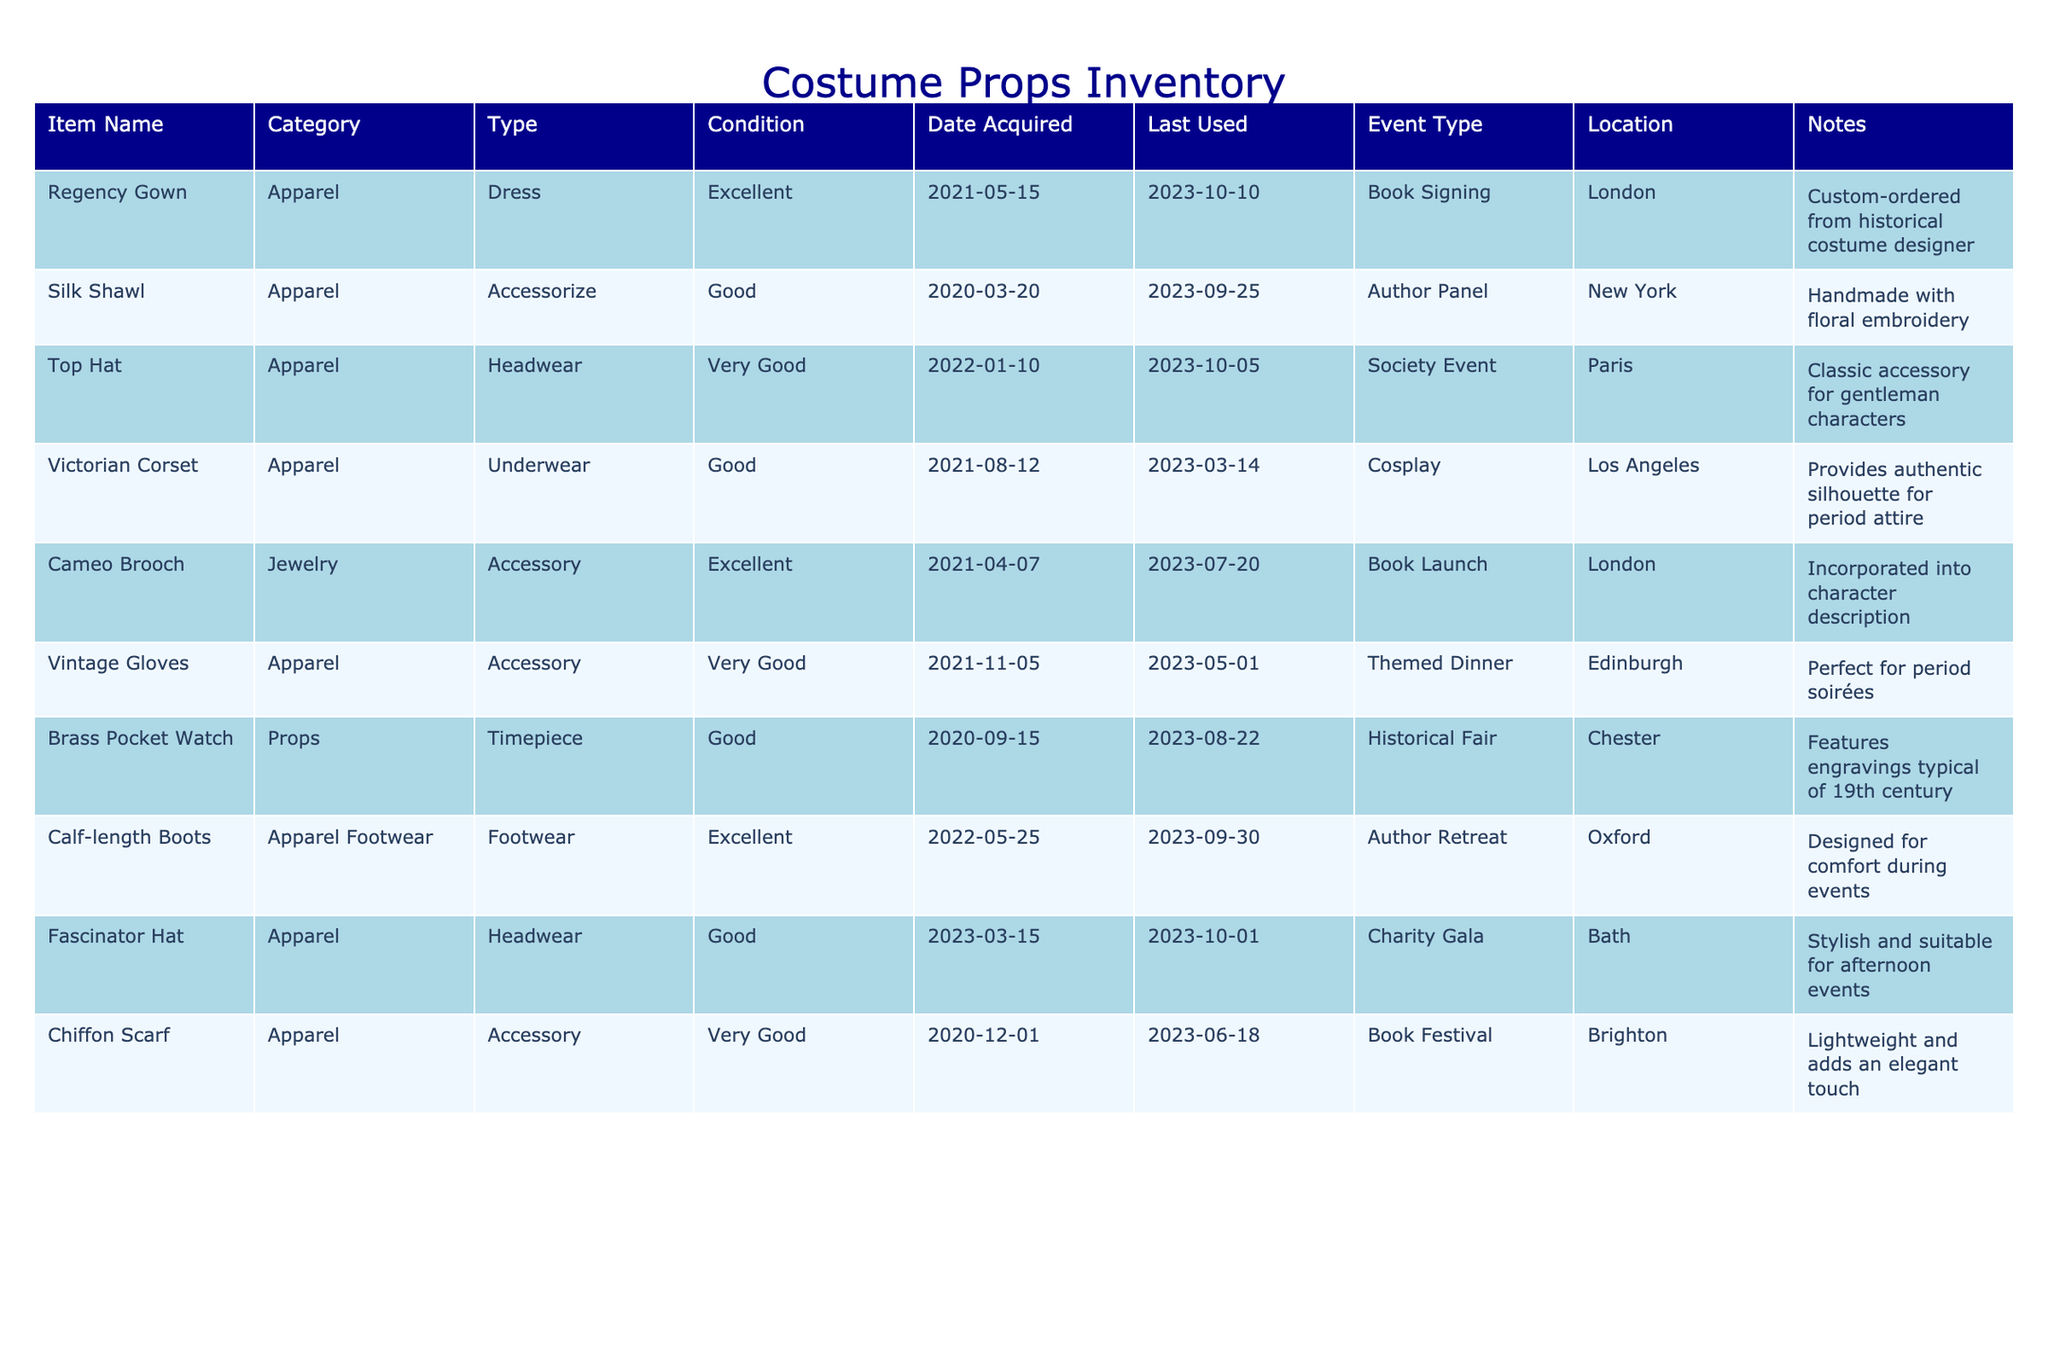What is the condition of the Silk Shawl? The condition of the Silk Shawl can be found by searching for its row in the table. It states that the condition is "Good".
Answer: Good When was the Victorian Corset last used? To find this information, locate the row for the Victorian Corset in the table, where the "Last Used" column indicates that it was last used on "2023-03-14".
Answer: 2023-03-14 How many items were acquired in the year 2021? A deeper examination of the "Date Acquired" column reveals that there are three items acquired in 2021: Regency Gown, Victorian Corset, and Cameo Brooch.
Answer: 3 Is the Top Hat suitable for a Society Event? Looking at the "Event Type" for Top Hat, it lists "Society Event", implying it is indeed suitable for such occasions.
Answer: Yes What is the average condition rating of the costume accessories? Evaluating the conditions listed (Excellent, Good, Very Good, etc.) and determining their assigned values (Excellent=2, Good=1, Very Good=1.5), we identify the condition ratings of the accessories: Silk Shawl (1), Cameo Brooch (2), Vintage Gloves (1.5), Chiffon Scarf (1.5). The average is calculated as (1 + 2 + 1.5 + 1.5) / 4 = 1.75.
Answer: 1.75 How often is the Brass Pocket Watch used for events? By assessing the dates in the "Last Used" column in relation to its "Date Acquired" (2020-09-15), we see it has been used in one event in 2023 -- this indicates it has been used sparingly over the two years since acquisition.
Answer: Sparingly Which item was custom-ordered from a historical costume designer? A direct look at the notes for the items reveals that the Regency Gown is the one that was custom-ordered from a historical costume designer.
Answer: Regency Gown What was the latest event the Calf-length Boots were used in? The latest event for the Calf-length Boots can be found by checking the "Last Used" column, and it states "2023-09-30". Thus, the latest event was held on this date.
Answer: 2023-09-30 Was the Fascinator Hat used before the year 2023? A review of the "Last Used" date for the Fascinator Hat shows it was last used on "2023-10-01", confirming it had not been used prior to 2023.
Answer: No 